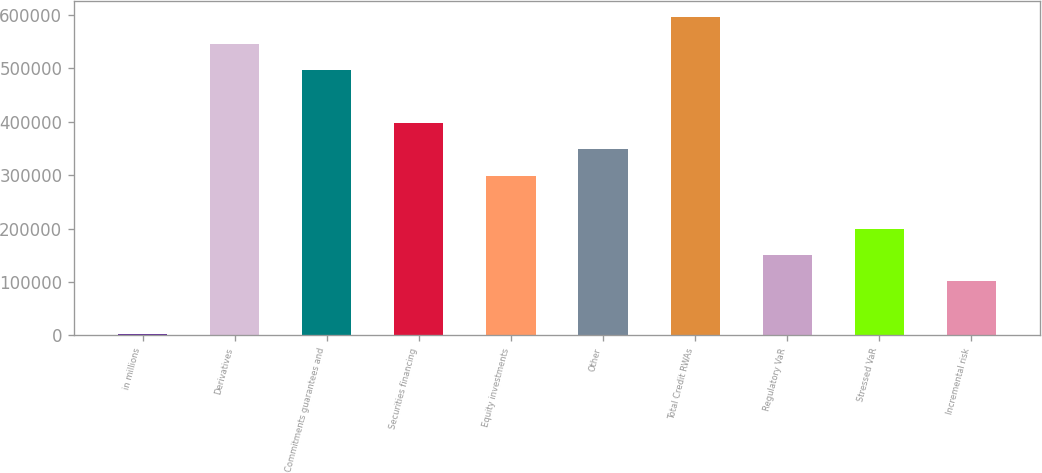Convert chart. <chart><loc_0><loc_0><loc_500><loc_500><bar_chart><fcel>in millions<fcel>Derivatives<fcel>Commitments guarantees and<fcel>Securities financing<fcel>Equity investments<fcel>Other<fcel>Total Credit RWAs<fcel>Regulatory VaR<fcel>Stressed VaR<fcel>Incremental risk<nl><fcel>2016<fcel>546142<fcel>496676<fcel>397744<fcel>298812<fcel>348278<fcel>595608<fcel>150414<fcel>199880<fcel>100948<nl></chart> 